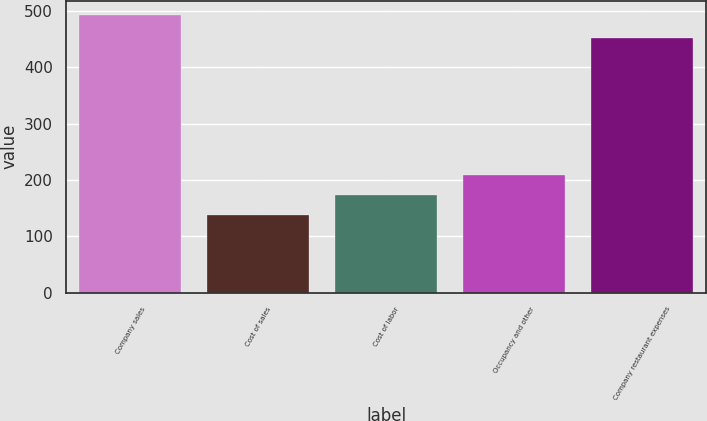<chart> <loc_0><loc_0><loc_500><loc_500><bar_chart><fcel>Company sales<fcel>Cost of sales<fcel>Cost of labor<fcel>Occupancy and other<fcel>Company restaurant expenses<nl><fcel>493<fcel>137<fcel>172.6<fcel>208.2<fcel>452<nl></chart> 